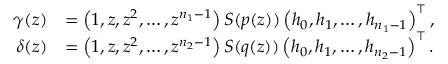Convert formula to latex. <formula><loc_0><loc_0><loc_500><loc_500>\begin{array} { r l } { \gamma ( z ) } & { = \left ( 1 , z , z ^ { 2 } , \dots , z ^ { n _ { 1 } - 1 } \right ) S ( p ( z ) ) \left ( h _ { 0 } , h _ { 1 } , \dots , h _ { n _ { 1 } - 1 } \right ) ^ { \top } , } \\ { \delta ( z ) } & { = \left ( 1 , z , z ^ { 2 } , \dots , z ^ { n _ { 2 } - 1 } \right ) S ( q ( z ) ) \left ( h _ { 0 } , h _ { 1 } , \dots , h _ { n _ { 2 } - 1 } \right ) ^ { \top } . } \end{array}</formula> 